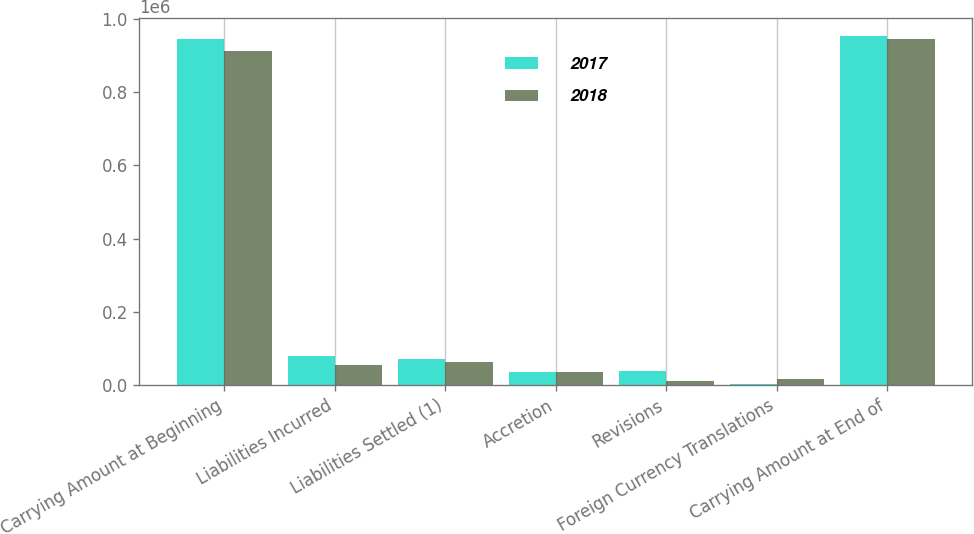<chart> <loc_0><loc_0><loc_500><loc_500><stacked_bar_chart><ecel><fcel>Carrying Amount at Beginning<fcel>Liabilities Incurred<fcel>Liabilities Settled (1)<fcel>Accretion<fcel>Revisions<fcel>Foreign Currency Translations<fcel>Carrying Amount at End of<nl><fcel>2017<fcel>946848<fcel>79057<fcel>70829<fcel>36622<fcel>38932<fcel>1611<fcel>954377<nl><fcel>2018<fcel>912926<fcel>54764<fcel>61871<fcel>34708<fcel>9818<fcel>16139<fcel>946848<nl></chart> 